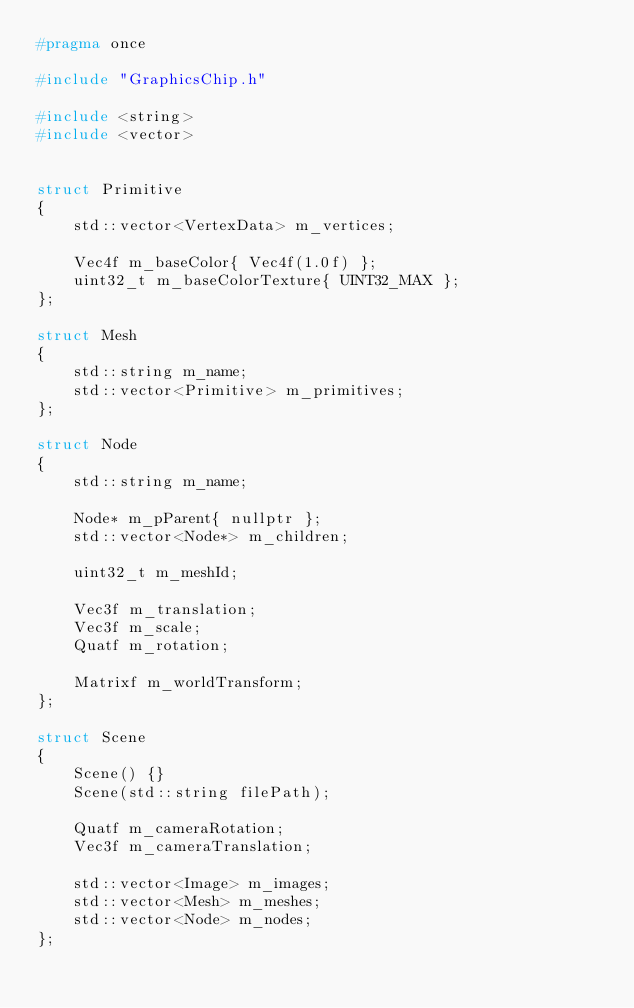<code> <loc_0><loc_0><loc_500><loc_500><_C_>#pragma once

#include "GraphicsChip.h"

#include <string>
#include <vector>


struct Primitive
{
    std::vector<VertexData> m_vertices;

    Vec4f m_baseColor{ Vec4f(1.0f) };
    uint32_t m_baseColorTexture{ UINT32_MAX };
};

struct Mesh
{
    std::string m_name;
    std::vector<Primitive> m_primitives;
};

struct Node
{
    std::string m_name;
    
    Node* m_pParent{ nullptr };
    std::vector<Node*> m_children;

    uint32_t m_meshId;

    Vec3f m_translation;
    Vec3f m_scale;
    Quatf m_rotation;

    Matrixf m_worldTransform;
};

struct Scene
{
    Scene() {}
    Scene(std::string filePath);

    Quatf m_cameraRotation;
    Vec3f m_cameraTranslation;

    std::vector<Image> m_images;
    std::vector<Mesh> m_meshes;
    std::vector<Node> m_nodes;
};</code> 